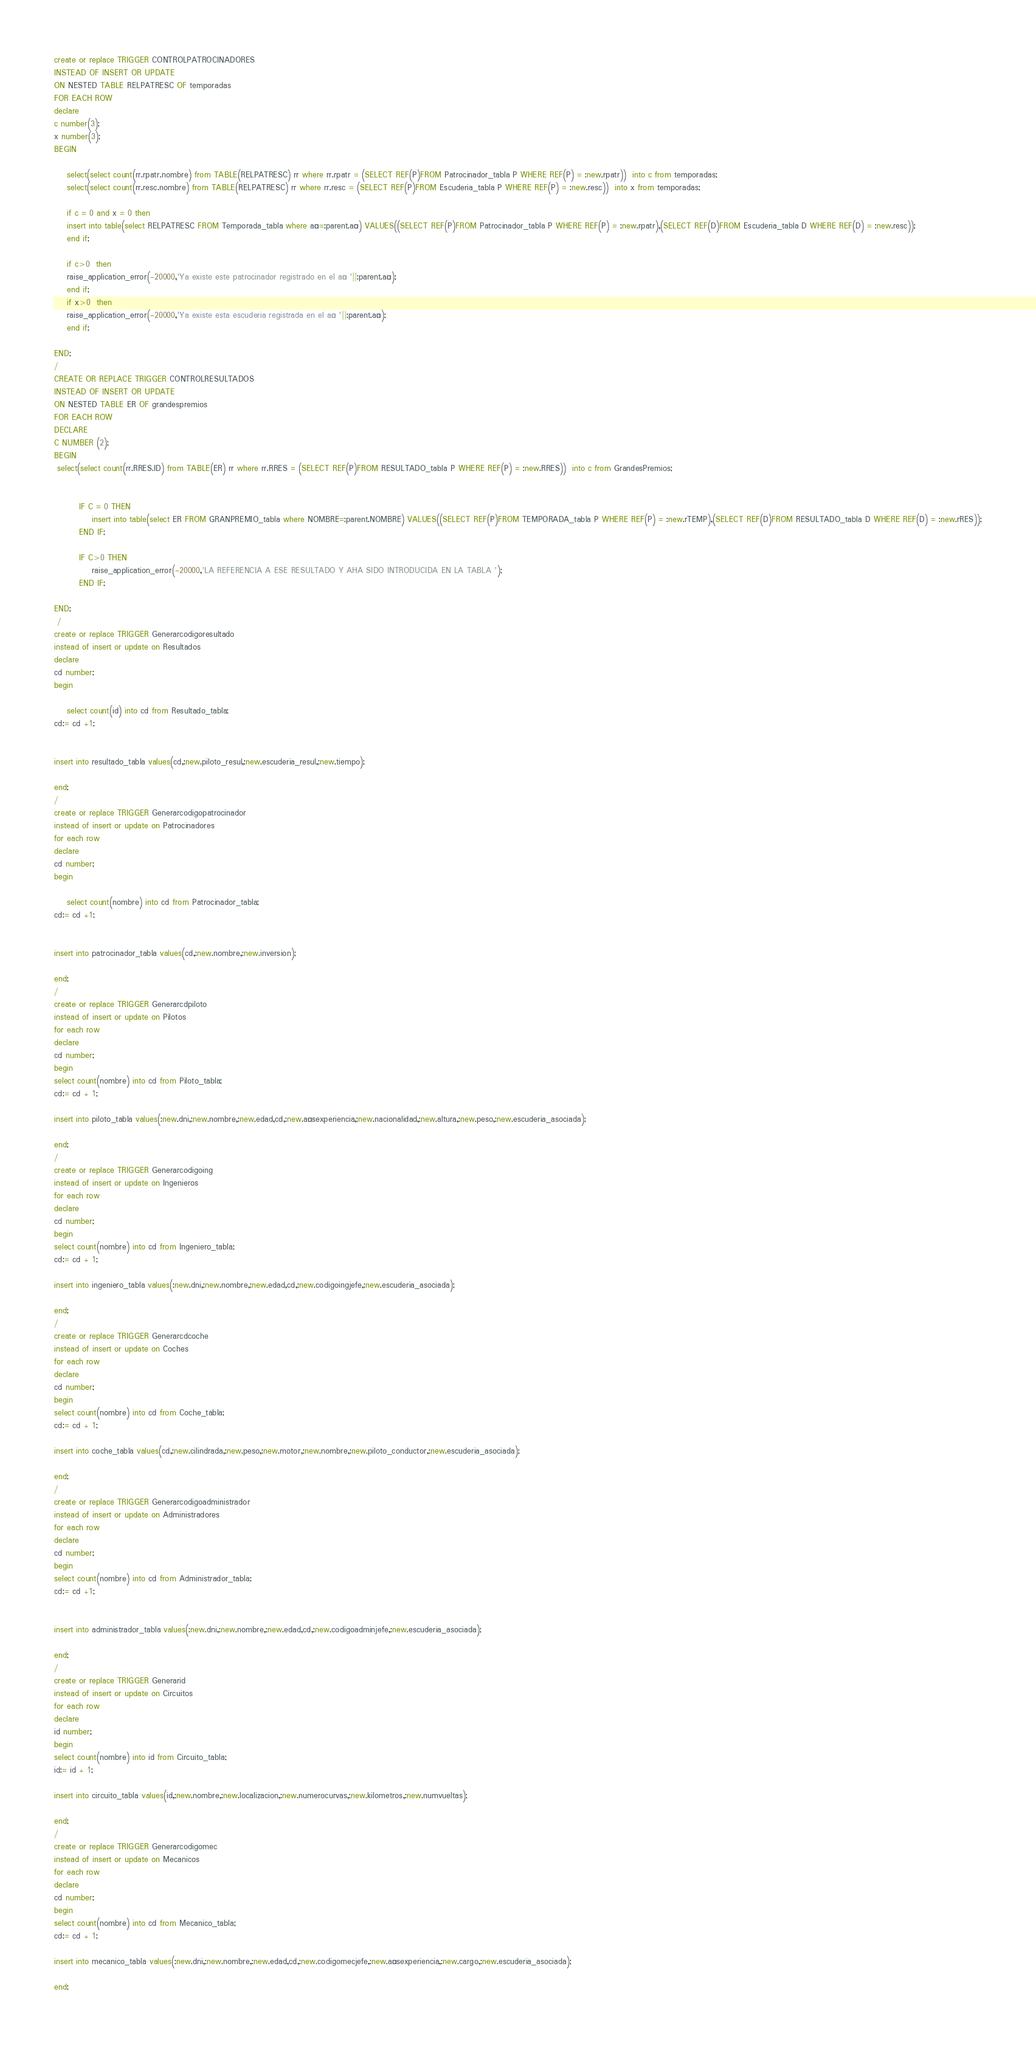Convert code to text. <code><loc_0><loc_0><loc_500><loc_500><_SQL_>create or replace TRIGGER CONTROLPATROCINADORES
INSTEAD OF INSERT OR UPDATE
ON NESTED TABLE RELPATRESC OF temporadas
FOR EACH ROW
declare
c number(3);
x number(3);
BEGIN

    select(select count(rr.rpatr.nombre) from TABLE(RELPATRESC) rr where rr.rpatr = (SELECT REF(P)FROM Patrocinador_tabla P WHERE REF(P) = :new.rpatr))  into c from temporadas;
    select(select count(rr.resc.nombre) from TABLE(RELPATRESC) rr where rr.resc = (SELECT REF(P)FROM Escuderia_tabla P WHERE REF(P) = :new.resc))  into x from temporadas;
    
    if c = 0 and x = 0 then
    insert into table(select RELPATRESC FROM Temporada_tabla where año=:parent.año) VALUES((SELECT REF(P)FROM Patrocinador_tabla P WHERE REF(P) = :new.rpatr),(SELECT REF(D)FROM Escuderia_tabla D WHERE REF(D) = :new.resc));
    end if;
    
    if c>0  then
    raise_application_error(-20000,'Ya existe este patrocinador registrado en el año '||:parent.año);
    end if;
    if x>0  then
    raise_application_error(-20000,'Ya existe esta escuderia registrada en el año '||:parent.año);
    end if;
    
END;
/
CREATE OR REPLACE TRIGGER CONTROLRESULTADOS
INSTEAD OF INSERT OR UPDATE
ON NESTED TABLE ER OF grandespremios
FOR EACH ROW
DECLARE
C NUMBER (2);
BEGIN
 select(select count(rr.RRES.ID) from TABLE(ER) rr where rr.RRES = (SELECT REF(P)FROM RESULTADO_tabla P WHERE REF(P) = :new.RRES))  into c from GrandesPremios;
 
 
        IF C = 0 THEN
            insert into table(select ER FROM GRANPREMIO_tabla where NOMBRE=:parent.NOMBRE) VALUES((SELECT REF(P)FROM TEMPORADA_tabla P WHERE REF(P) = :new.rTEMP),(SELECT REF(D)FROM RESULTADO_tabla D WHERE REF(D) = :new.rRES));
        END IF;
        
        IF C>0 THEN
            raise_application_error(-20000,'LA REFERENCIA A ESE RESULTADO Y AHA SIDO INTRODUCIDA EN LA TABLA ');
        END IF;
 
END;
 /
create or replace TRIGGER Generarcodigoresultado
instead of insert or update on Resultados
declare
cd number;
begin
    
    select count(id) into cd from Resultado_tabla;
cd:= cd +1;


insert into resultado_tabla values(cd,:new.piloto_resul,:new.escuderia_resul,:new.tiempo);

end;
/
create or replace TRIGGER Generarcodigopatrocinador
instead of insert or update on Patrocinadores
for each row
declare
cd number;
begin
    
    select count(nombre) into cd from Patrocinador_tabla;
cd:= cd +1;


insert into patrocinador_tabla values(cd,:new.nombre,:new.inversion);

end;
/
create or replace TRIGGER Generarcdpiloto
instead of insert or update on Pilotos
for each row
declare
cd number;
begin
select count(nombre) into cd from Piloto_tabla;
cd:= cd + 1;

insert into piloto_tabla values(:new.dni,:new.nombre,:new.edad,cd,:new.añosexperiencia,:new.nacionalidad,:new.altura,:new.peso,:new.escuderia_asociada);

end;
/
create or replace TRIGGER Generarcodigoing
instead of insert or update on Ingenieros
for each row
declare
cd number;
begin
select count(nombre) into cd from Ingeniero_tabla;
cd:= cd + 1;

insert into ingeniero_tabla values(:new.dni,:new.nombre,:new.edad,cd,:new.codigoingjefe,:new.escuderia_asociada);

end;
/
create or replace TRIGGER Generarcdcoche
instead of insert or update on Coches
for each row
declare
cd number;
begin
select count(nombre) into cd from Coche_tabla;
cd:= cd + 1;

insert into coche_tabla values(cd,:new.cilindrada,:new.peso,:new.motor,:new.nombre,:new.piloto_conductor,:new.escuderia_asociada);

end;
/
create or replace TRIGGER Generarcodigoadministrador
instead of insert or update on Administradores
for each row
declare
cd number;
begin
select count(nombre) into cd from Administrador_tabla;
cd:= cd +1;


insert into administrador_tabla values(:new.dni,:new.nombre,:new.edad,cd,:new.codigoadminjefe,:new.escuderia_asociada);

end;
/
create or replace TRIGGER Generarid
instead of insert or update on Circuitos
for each row
declare
id number;
begin
select count(nombre) into id from Circuito_tabla;
id:= id + 1;

insert into circuito_tabla values(id,:new.nombre,:new.localizacion,:new.numerocurvas,:new.kilometros,:new.numvueltas);

end;
/
create or replace TRIGGER Generarcodigomec
instead of insert or update on Mecanicos
for each row
declare
cd number;
begin
select count(nombre) into cd from Mecanico_tabla;
cd:= cd + 1;

insert into mecanico_tabla values(:new.dni,:new.nombre,:new.edad,cd,:new.codigomecjefe,:new.añosexperiencia,:new.cargo,:new.escuderia_asociada);

end;</code> 